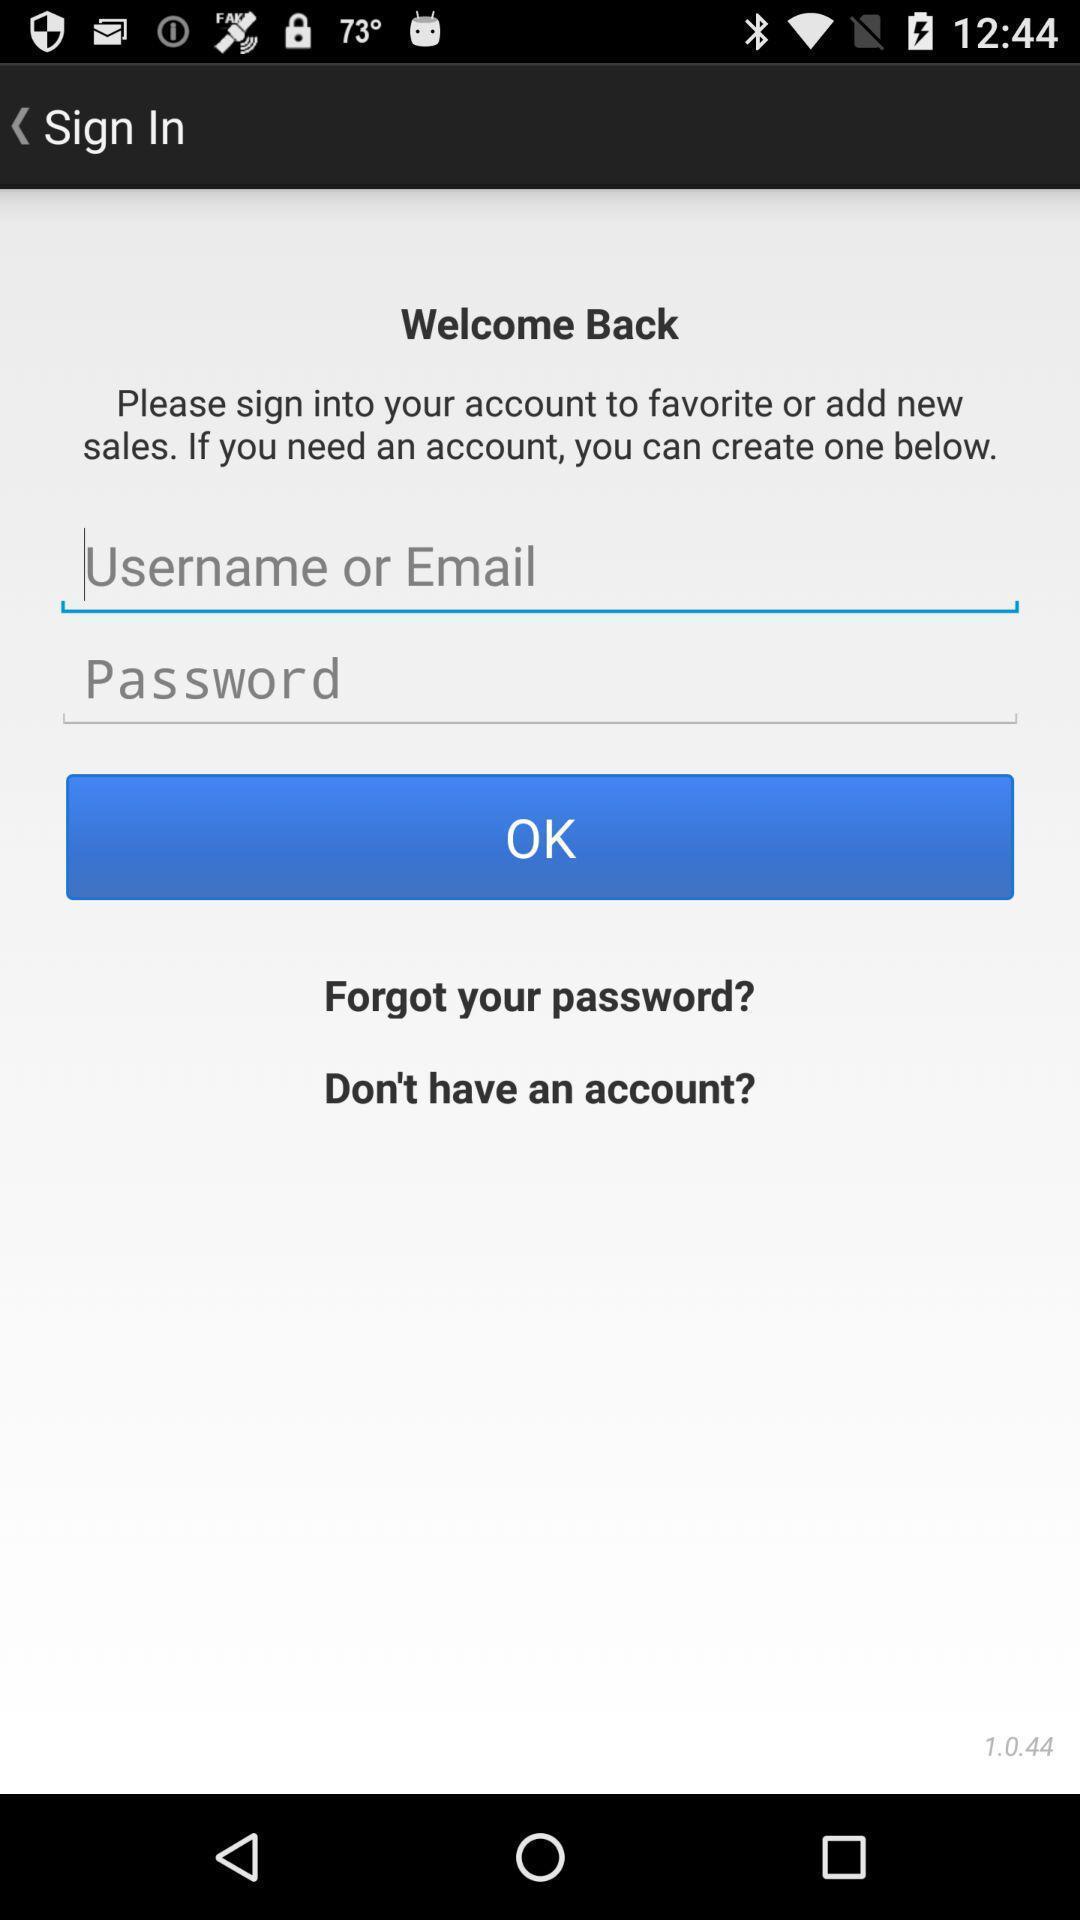Please provide a description for this image. Sign in page for the sales account. 